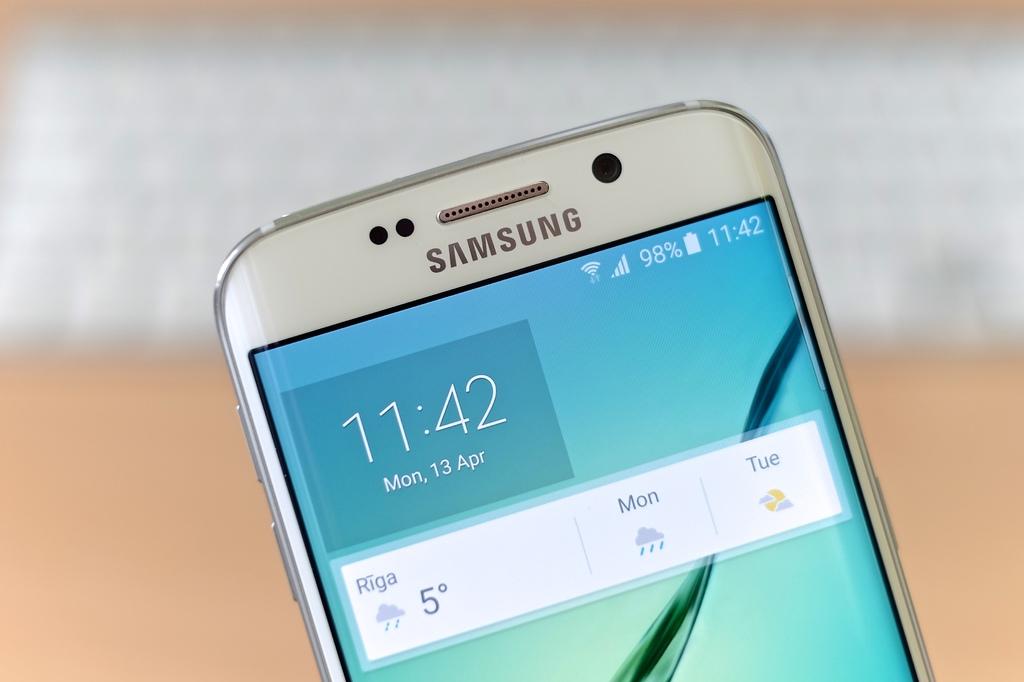What date is on the phone?
Give a very brief answer. Mon, 13 apr. What brand of cell phone is this?
Offer a very short reply. Samsung. 